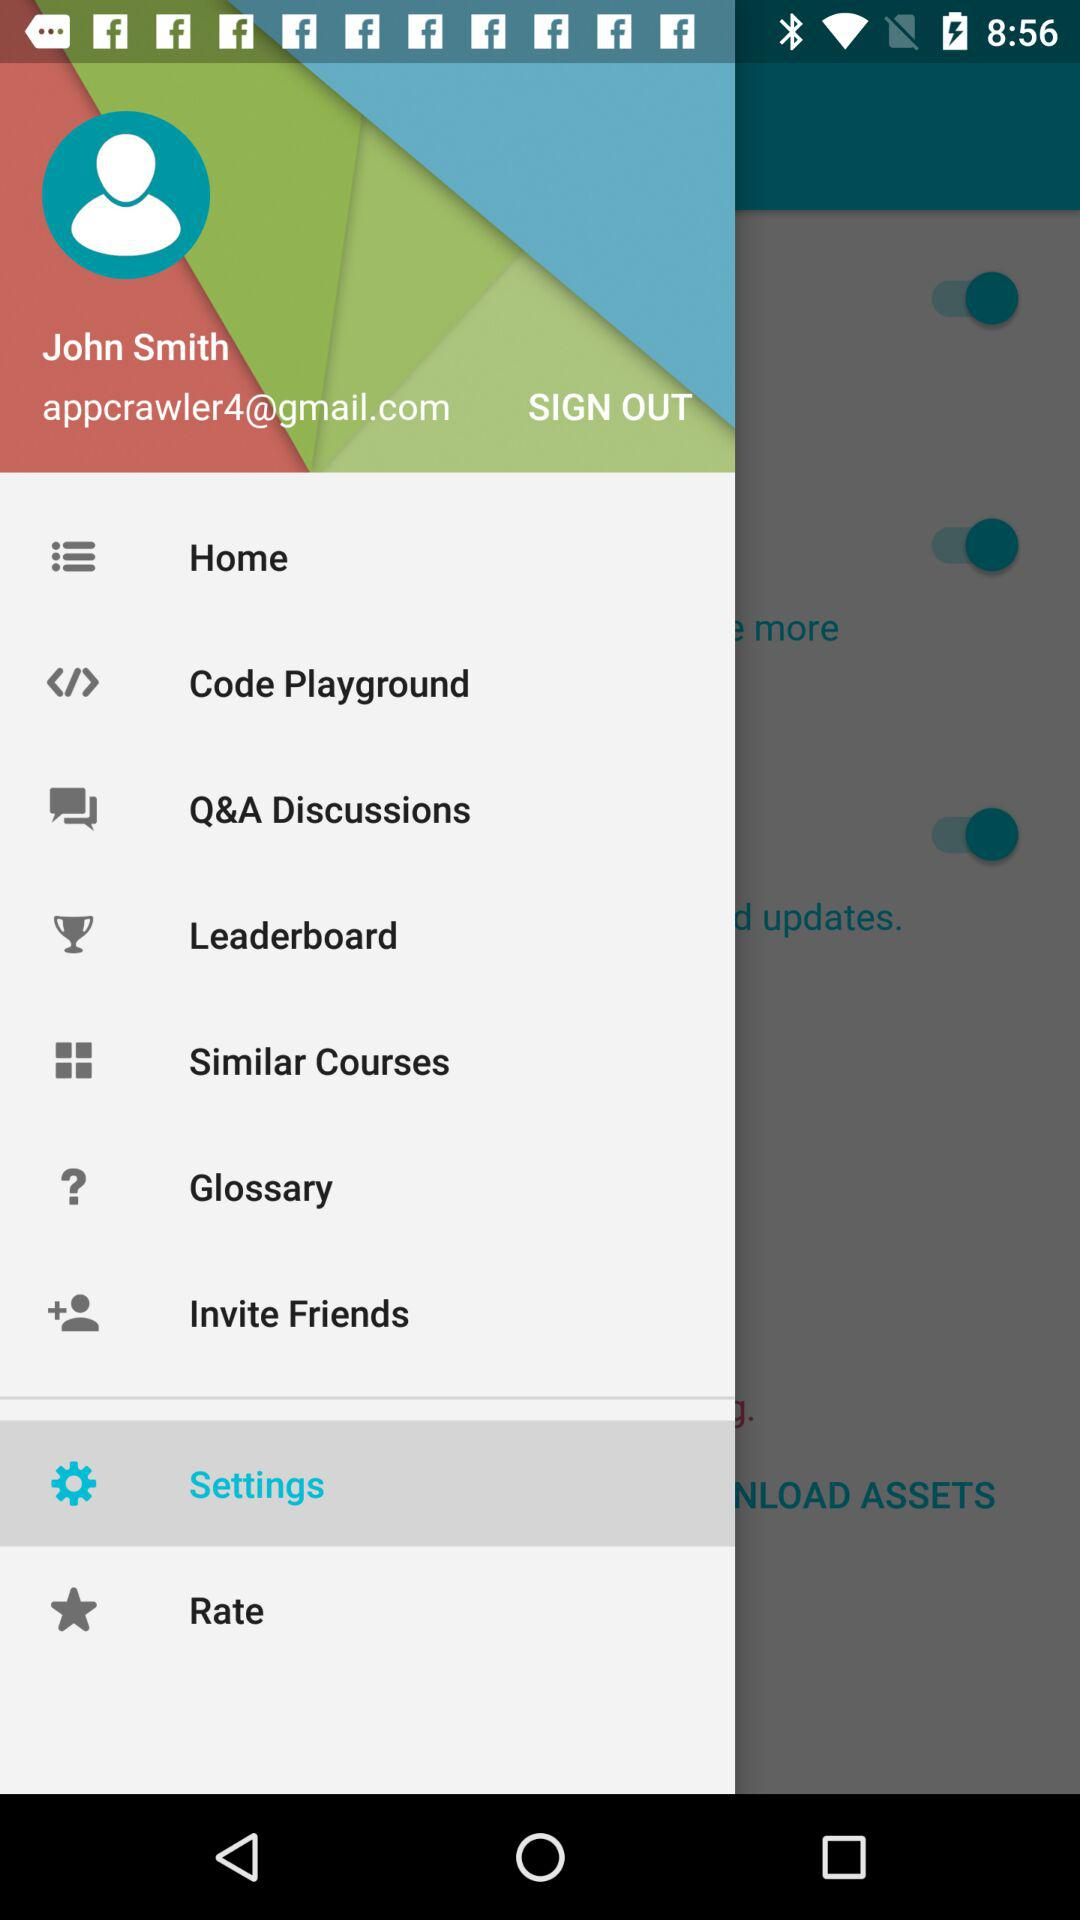Which is the selected item in the menu? The selected item in the menu is "Settings". 